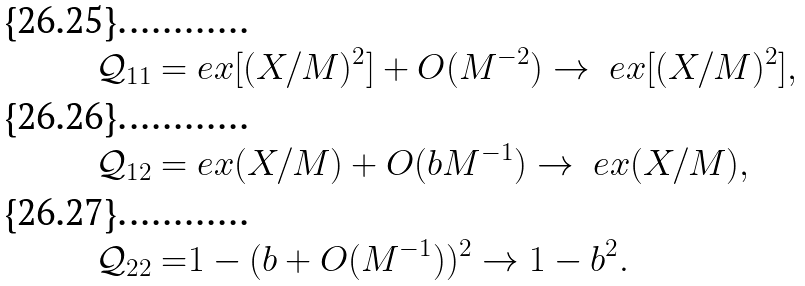Convert formula to latex. <formula><loc_0><loc_0><loc_500><loc_500>\mathcal { Q } _ { 1 1 } = & \ e x [ ( X / M ) ^ { 2 } ] + O ( M ^ { - 2 } ) \to \ e x [ ( X / M ) ^ { 2 } ] , \\ \mathcal { Q } _ { 1 2 } = & \ e x ( X / M ) + O ( b M ^ { - 1 } ) \to \ e x ( X / M ) , \\ \mathcal { Q } _ { 2 2 } = & 1 - ( b + O ( M ^ { - 1 } ) ) ^ { 2 } \to 1 - b ^ { 2 } .</formula> 